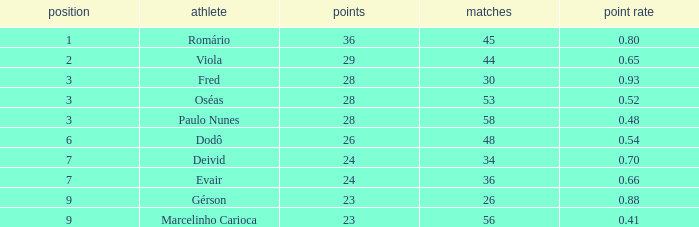In how many instances does the goal ratio have a ranking of 2 and involve more than 44 games? 0.0. 